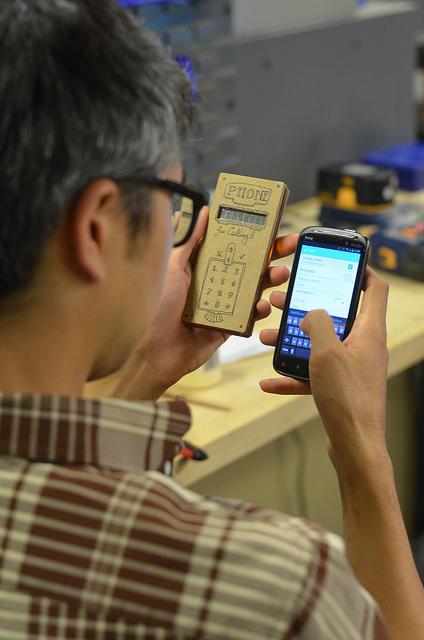What is the typing on?
Be succinct. Phone. What is the person holding in their left hand?
Write a very short answer. Calculator. What is the man doing?
Keep it brief. Texting. Is the man wearing glasses?
Be succinct. Yes. What color is his hair?
Quick response, please. Gray. Is this person in an office?
Be succinct. Yes. 